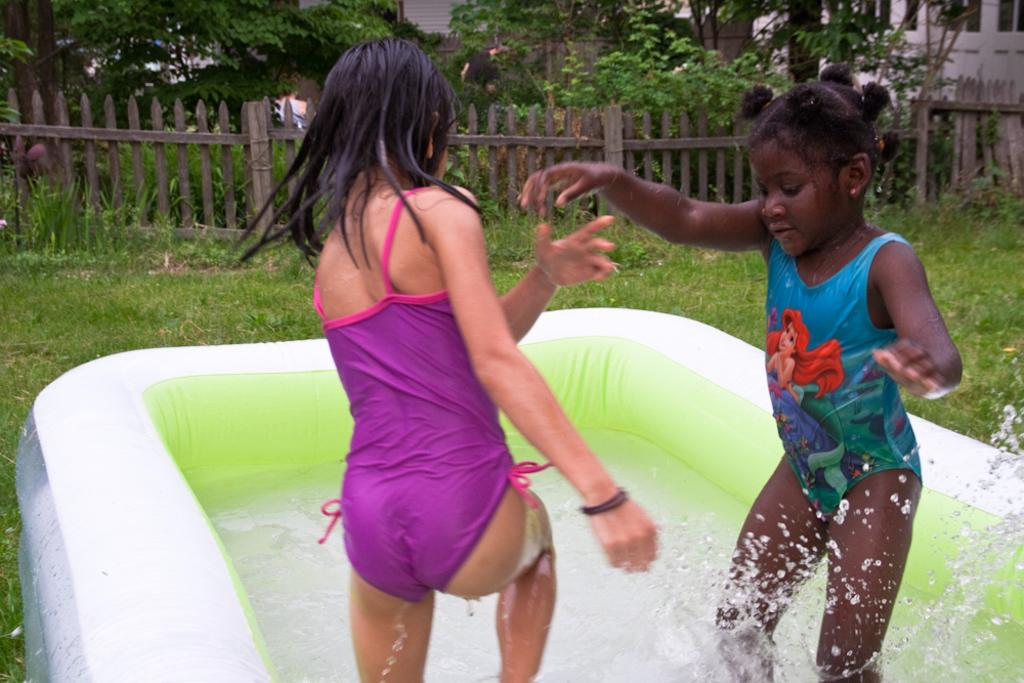What is in the tub that is visible in the image? There is water in the tub in the image. What are the two persons in the image doing? They are playing in the water. What type of vegetation is visible in the background of the image? There are trees in the background of the image. What can be seen behind the trees in the image? There is a fence and a building in the background of the image. What type of bean is being used as a hobby by the persons in the image? There is no bean present in the image, and the persons are not engaging in any hobbies related to beans. What journey are the persons in the image taking while playing in the water? The persons in the image are not taking any journey; they are simply playing in the water. 